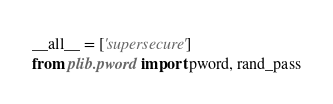Convert code to text. <code><loc_0><loc_0><loc_500><loc_500><_Python_>__all__ = ['supersecure']
from plib.pword import pword, rand_pass
</code> 